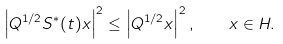Convert formula to latex. <formula><loc_0><loc_0><loc_500><loc_500>\left | Q ^ { 1 / 2 } S ^ { * } ( t ) x \right | ^ { 2 } \leq \left | Q ^ { 1 / 2 } x \right | ^ { 2 } , \quad x \in H .</formula> 